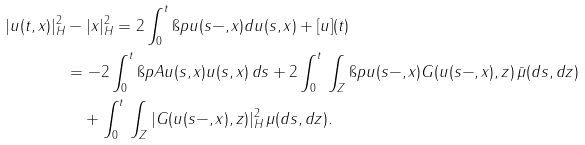<formula> <loc_0><loc_0><loc_500><loc_500>| u ( t , x ) | ^ { 2 } _ { H } & - | x | _ { H } ^ { 2 } = 2 \int _ { 0 } ^ { t } \i p { u ( s - , x ) } { d u ( s , x ) } + [ u ] ( t ) \\ & = - 2 \int _ { 0 } ^ { t } \i p { A u ( s , x ) } { u ( s , x ) } \, d s + 2 \int _ { 0 } ^ { t } \, \int _ { Z } \i p { u ( s - , x ) } { G ( u ( s - , x ) , z ) } \, \bar { \mu } ( d s , d z ) \\ & \quad + \int _ { 0 } ^ { t } \, \int _ { Z } | G ( u ( s - , x ) , z ) | _ { H } ^ { 2 } \, \mu ( d s , d z ) .</formula> 